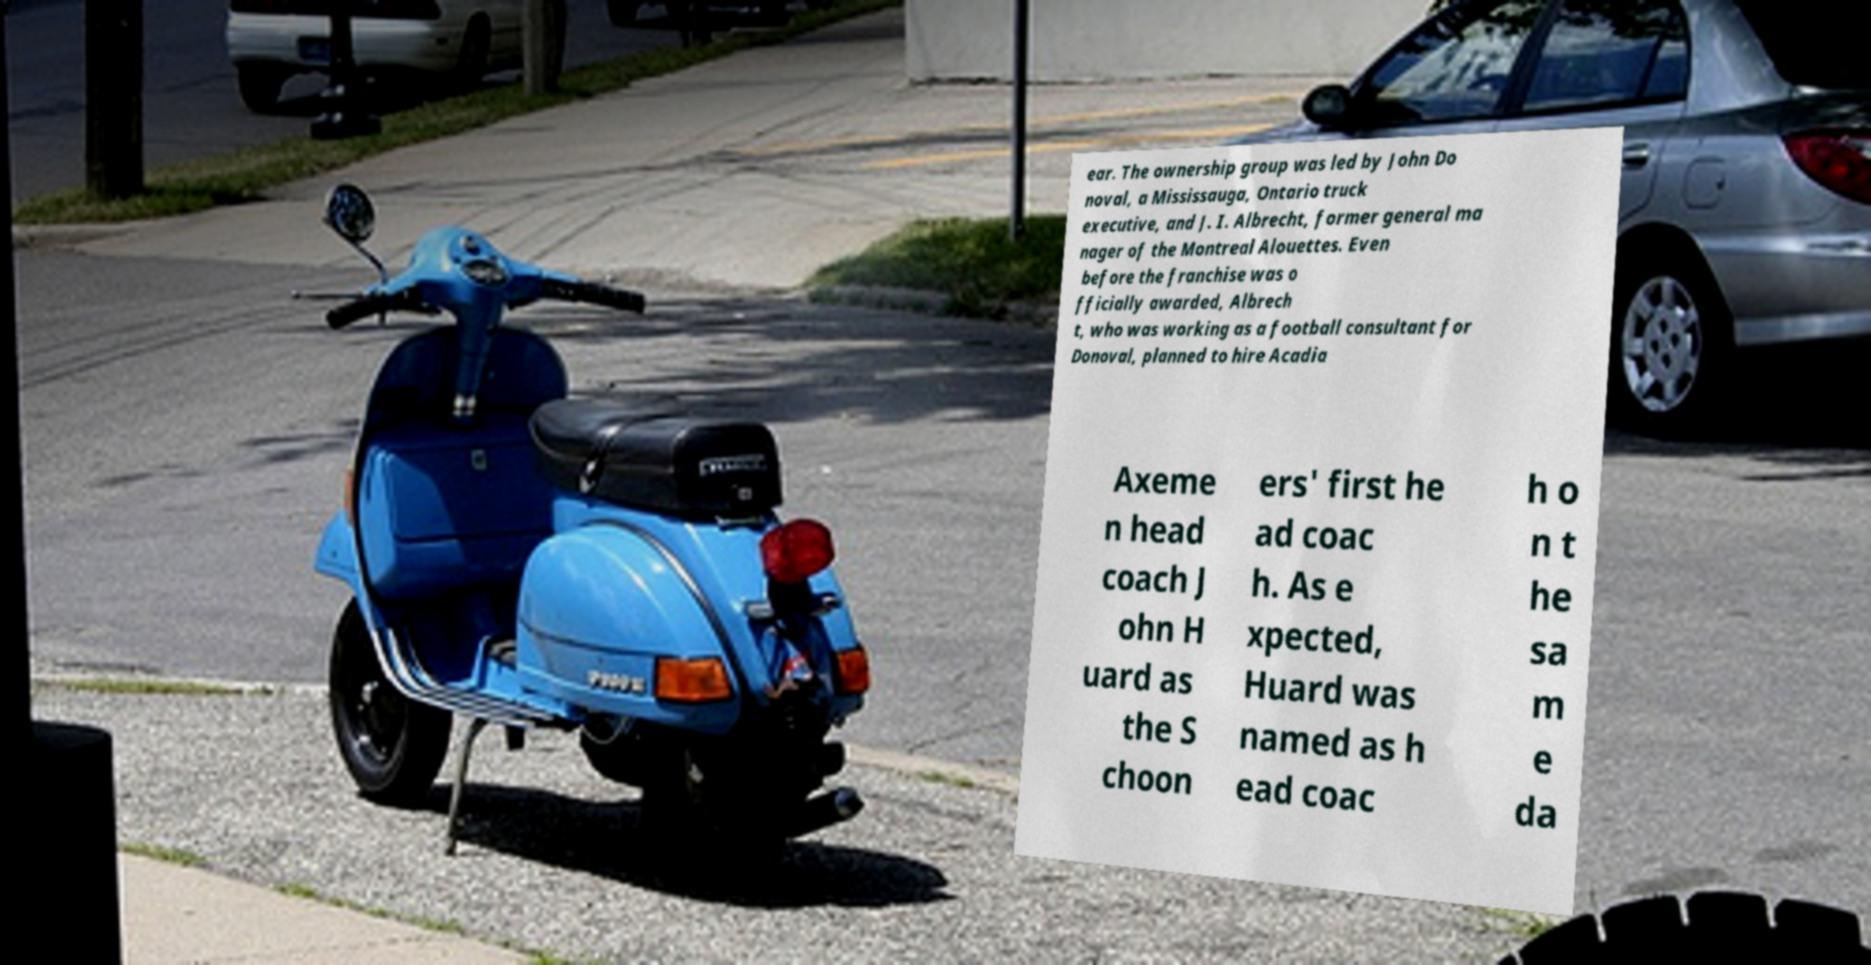There's text embedded in this image that I need extracted. Can you transcribe it verbatim? ear. The ownership group was led by John Do noval, a Mississauga, Ontario truck executive, and J. I. Albrecht, former general ma nager of the Montreal Alouettes. Even before the franchise was o fficially awarded, Albrech t, who was working as a football consultant for Donoval, planned to hire Acadia Axeme n head coach J ohn H uard as the S choon ers' first he ad coac h. As e xpected, Huard was named as h ead coac h o n t he sa m e da 